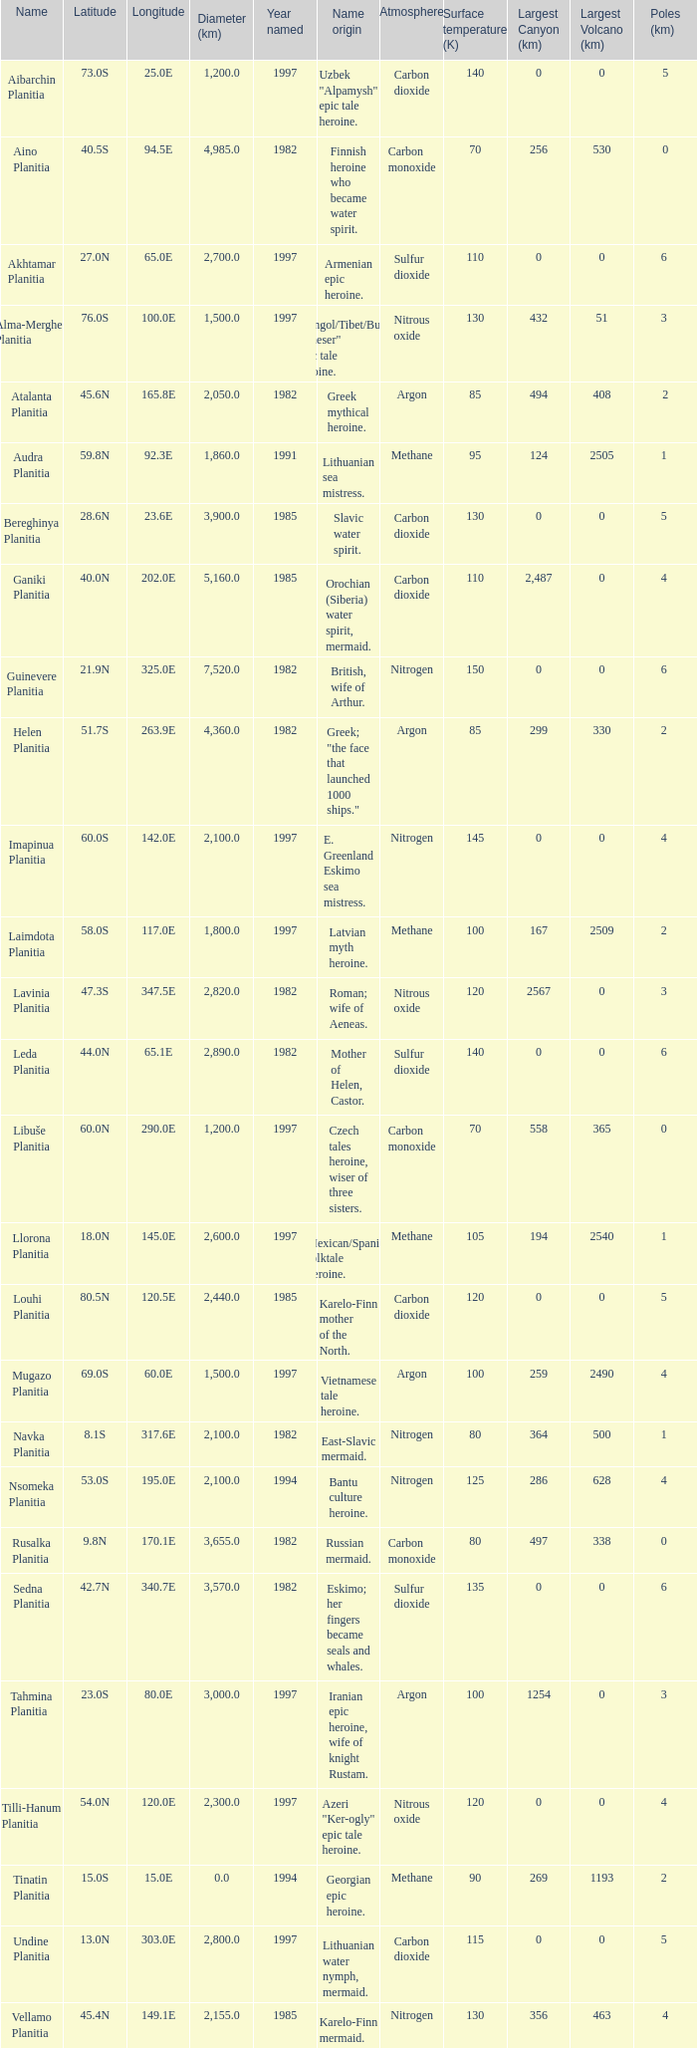What is the diameter (km) of feature of latitude 40.5s 4985.0. 